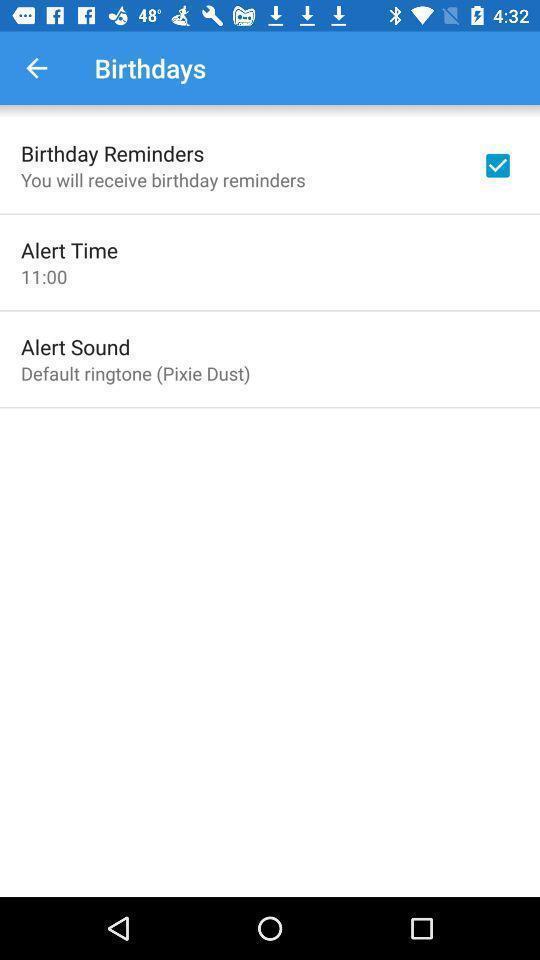Provide a description of this screenshot. Remainder page. 